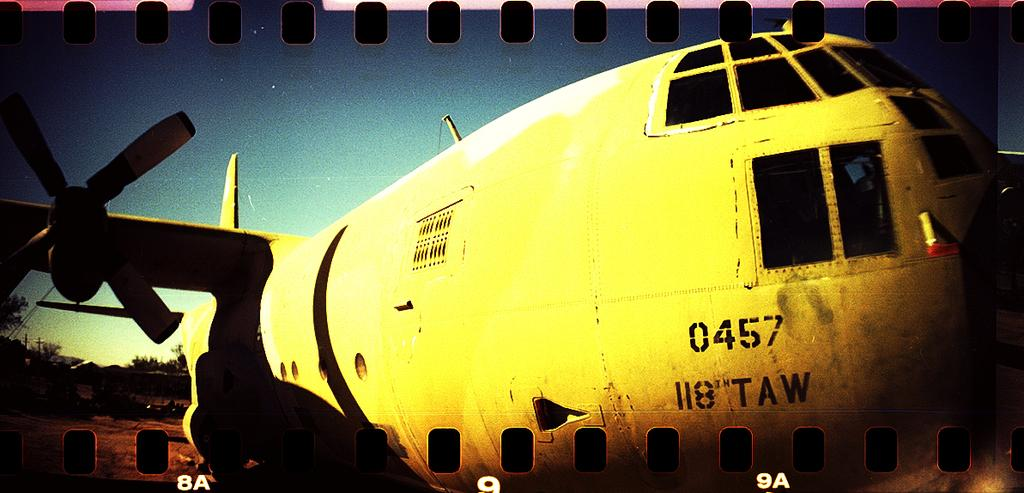What is the main subject of the image? The main subject of the image is an airplane. What can be seen on the left side of the image? There are trees on the left side of the image. Can you describe any additional features of the image? Yes, there is a watermark visible on the image. What type of feeling is being expressed by the head in the image? There is no head present in the image, as it features an airplane and trees. 